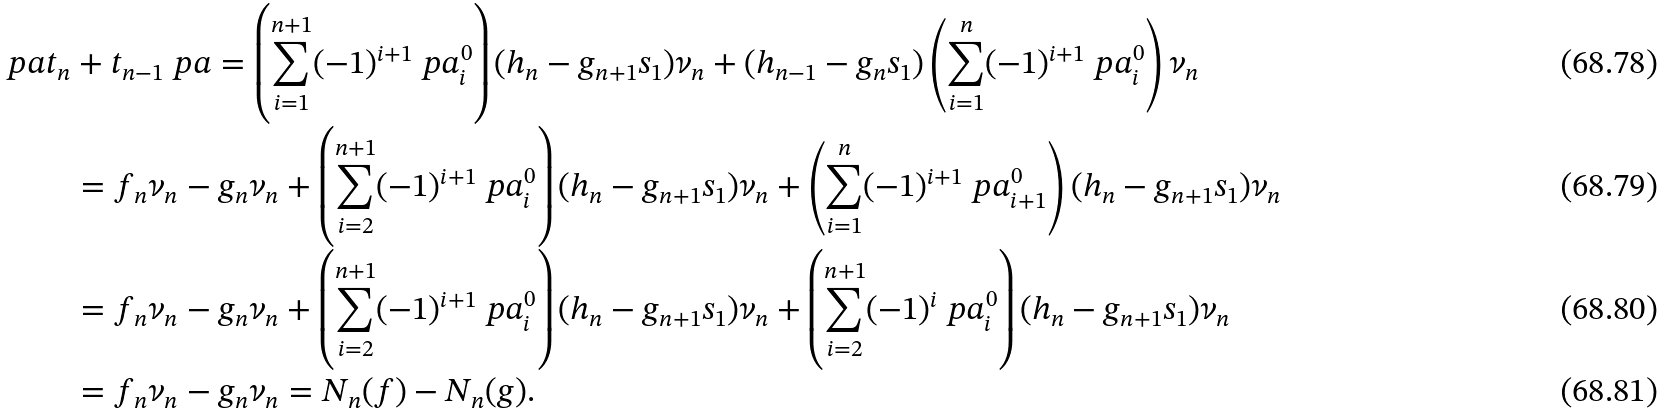<formula> <loc_0><loc_0><loc_500><loc_500>\ p a t _ { n } & + t _ { n - 1 } \ p a = \left ( \sum _ { i = 1 } ^ { n + 1 } ( - 1 ) ^ { i + 1 } \ p a _ { i } ^ { 0 } \right ) ( h _ { n } - g _ { n + 1 } s _ { 1 } ) \nu _ { n } + ( h _ { n - 1 } - g _ { n } s _ { 1 } ) \left ( \sum _ { i = 1 } ^ { n } ( - 1 ) ^ { i + 1 } \ p a _ { i } ^ { 0 } \right ) \nu _ { n } \\ & = f _ { n } \nu _ { n } - g _ { n } \nu _ { n } + \left ( \sum _ { i = 2 } ^ { n + 1 } ( - 1 ) ^ { i + 1 } \ p a _ { i } ^ { 0 } \right ) ( h _ { n } - g _ { n + 1 } s _ { 1 } ) \nu _ { n } + \left ( \sum _ { i = 1 } ^ { n } ( - 1 ) ^ { i + 1 } \ p a _ { i + 1 } ^ { 0 } \right ) ( h _ { n } - g _ { n + 1 } s _ { 1 } ) \nu _ { n } \\ & = f _ { n } \nu _ { n } - g _ { n } \nu _ { n } + \left ( \sum _ { i = 2 } ^ { n + 1 } ( - 1 ) ^ { i + 1 } \ p a _ { i } ^ { 0 } \right ) ( h _ { n } - g _ { n + 1 } s _ { 1 } ) \nu _ { n } + \left ( \sum _ { i = 2 } ^ { n + 1 } ( - 1 ) ^ { i } \ p a _ { i } ^ { 0 } \right ) ( h _ { n } - g _ { n + 1 } s _ { 1 } ) \nu _ { n } \\ & = f _ { n } \nu _ { n } - g _ { n } \nu _ { n } = N _ { n } ( f ) - N _ { n } ( g ) .</formula> 